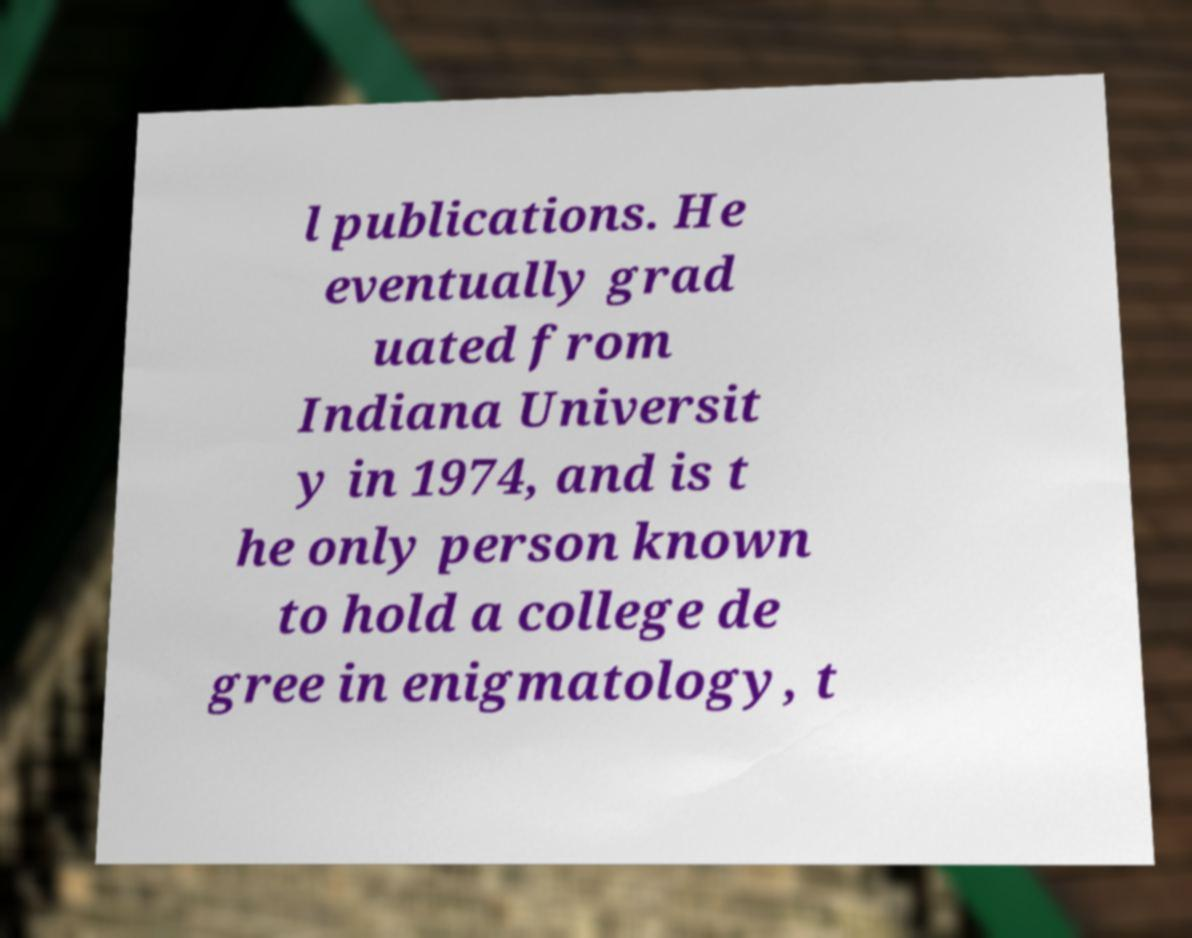Please identify and transcribe the text found in this image. l publications. He eventually grad uated from Indiana Universit y in 1974, and is t he only person known to hold a college de gree in enigmatology, t 